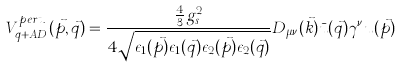<formula> <loc_0><loc_0><loc_500><loc_500>V ^ { p e r t . } _ { q + A D } ( \vec { p } , \vec { q } ) = \frac { \frac { 4 } { 3 } g ^ { 2 } _ { s } } { 4 \sqrt { \epsilon _ { 1 } ( \vec { p } ) \epsilon _ { 1 } ( \vec { q } ) \epsilon _ { 2 } ( \vec { p } ) \epsilon _ { 2 } ( \vec { q } ) } } D _ { \mu \nu } ( \vec { k } ) \bar { u } ( \vec { q } ) \gamma ^ { \nu } u ( \vec { p } )</formula> 